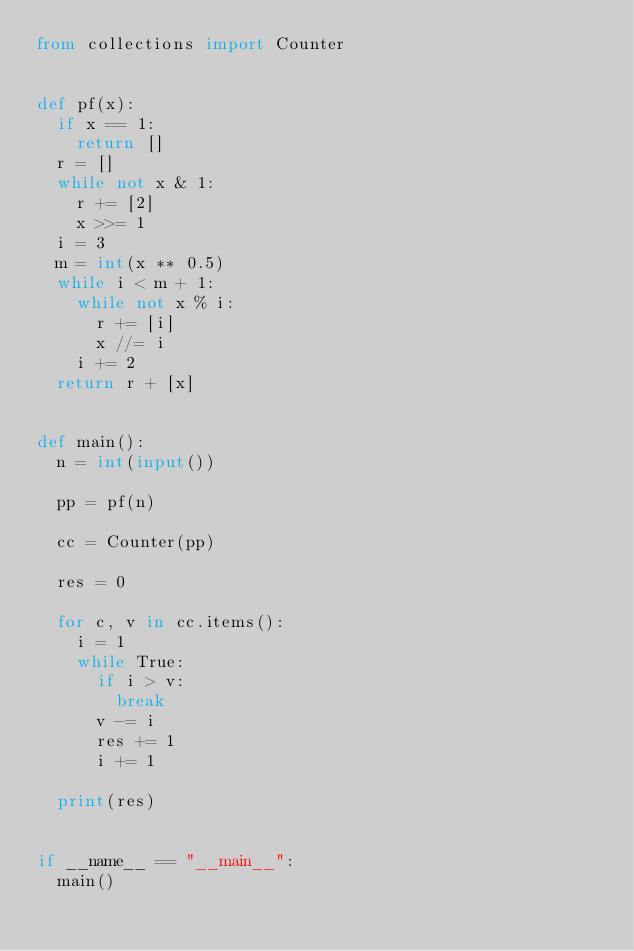Convert code to text. <code><loc_0><loc_0><loc_500><loc_500><_Python_>from collections import Counter


def pf(x):
  if x == 1:
    return []
  r = []
  while not x & 1:
    r += [2]
    x >>= 1
  i = 3
  m = int(x ** 0.5)
  while i < m + 1:
    while not x % i:
      r += [i]
      x //= i
    i += 2
  return r + [x]


def main():
  n = int(input())
  
  pp = pf(n)
 
  cc = Counter(pp)
  
  res = 0
  
  for c, v in cc.items():
    i = 1
    while True:
      if i > v:
        break
      v -= i
      res += 1
      i += 1
      
  print(res)


if __name__ == "__main__":
  main()
</code> 